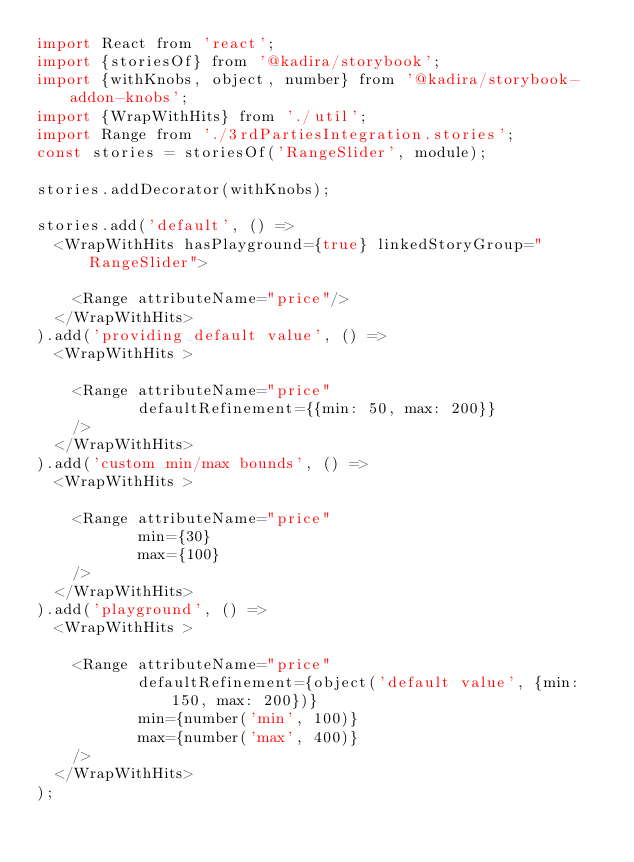Convert code to text. <code><loc_0><loc_0><loc_500><loc_500><_JavaScript_>import React from 'react';
import {storiesOf} from '@kadira/storybook';
import {withKnobs, object, number} from '@kadira/storybook-addon-knobs';
import {WrapWithHits} from './util';
import Range from './3rdPartiesIntegration.stories';
const stories = storiesOf('RangeSlider', module);

stories.addDecorator(withKnobs);

stories.add('default', () =>
  <WrapWithHits hasPlayground={true} linkedStoryGroup="RangeSlider">

    <Range attributeName="price"/>
  </WrapWithHits>
).add('providing default value', () =>
  <WrapWithHits >

    <Range attributeName="price"
           defaultRefinement={{min: 50, max: 200}}
    />
  </WrapWithHits>
).add('custom min/max bounds', () =>
  <WrapWithHits >

    <Range attributeName="price"
           min={30}
           max={100}
    />
  </WrapWithHits>
).add('playground', () =>
  <WrapWithHits >

    <Range attributeName="price"
           defaultRefinement={object('default value', {min: 150, max: 200})}
           min={number('min', 100)}
           max={number('max', 400)}
    />
  </WrapWithHits>
);
</code> 